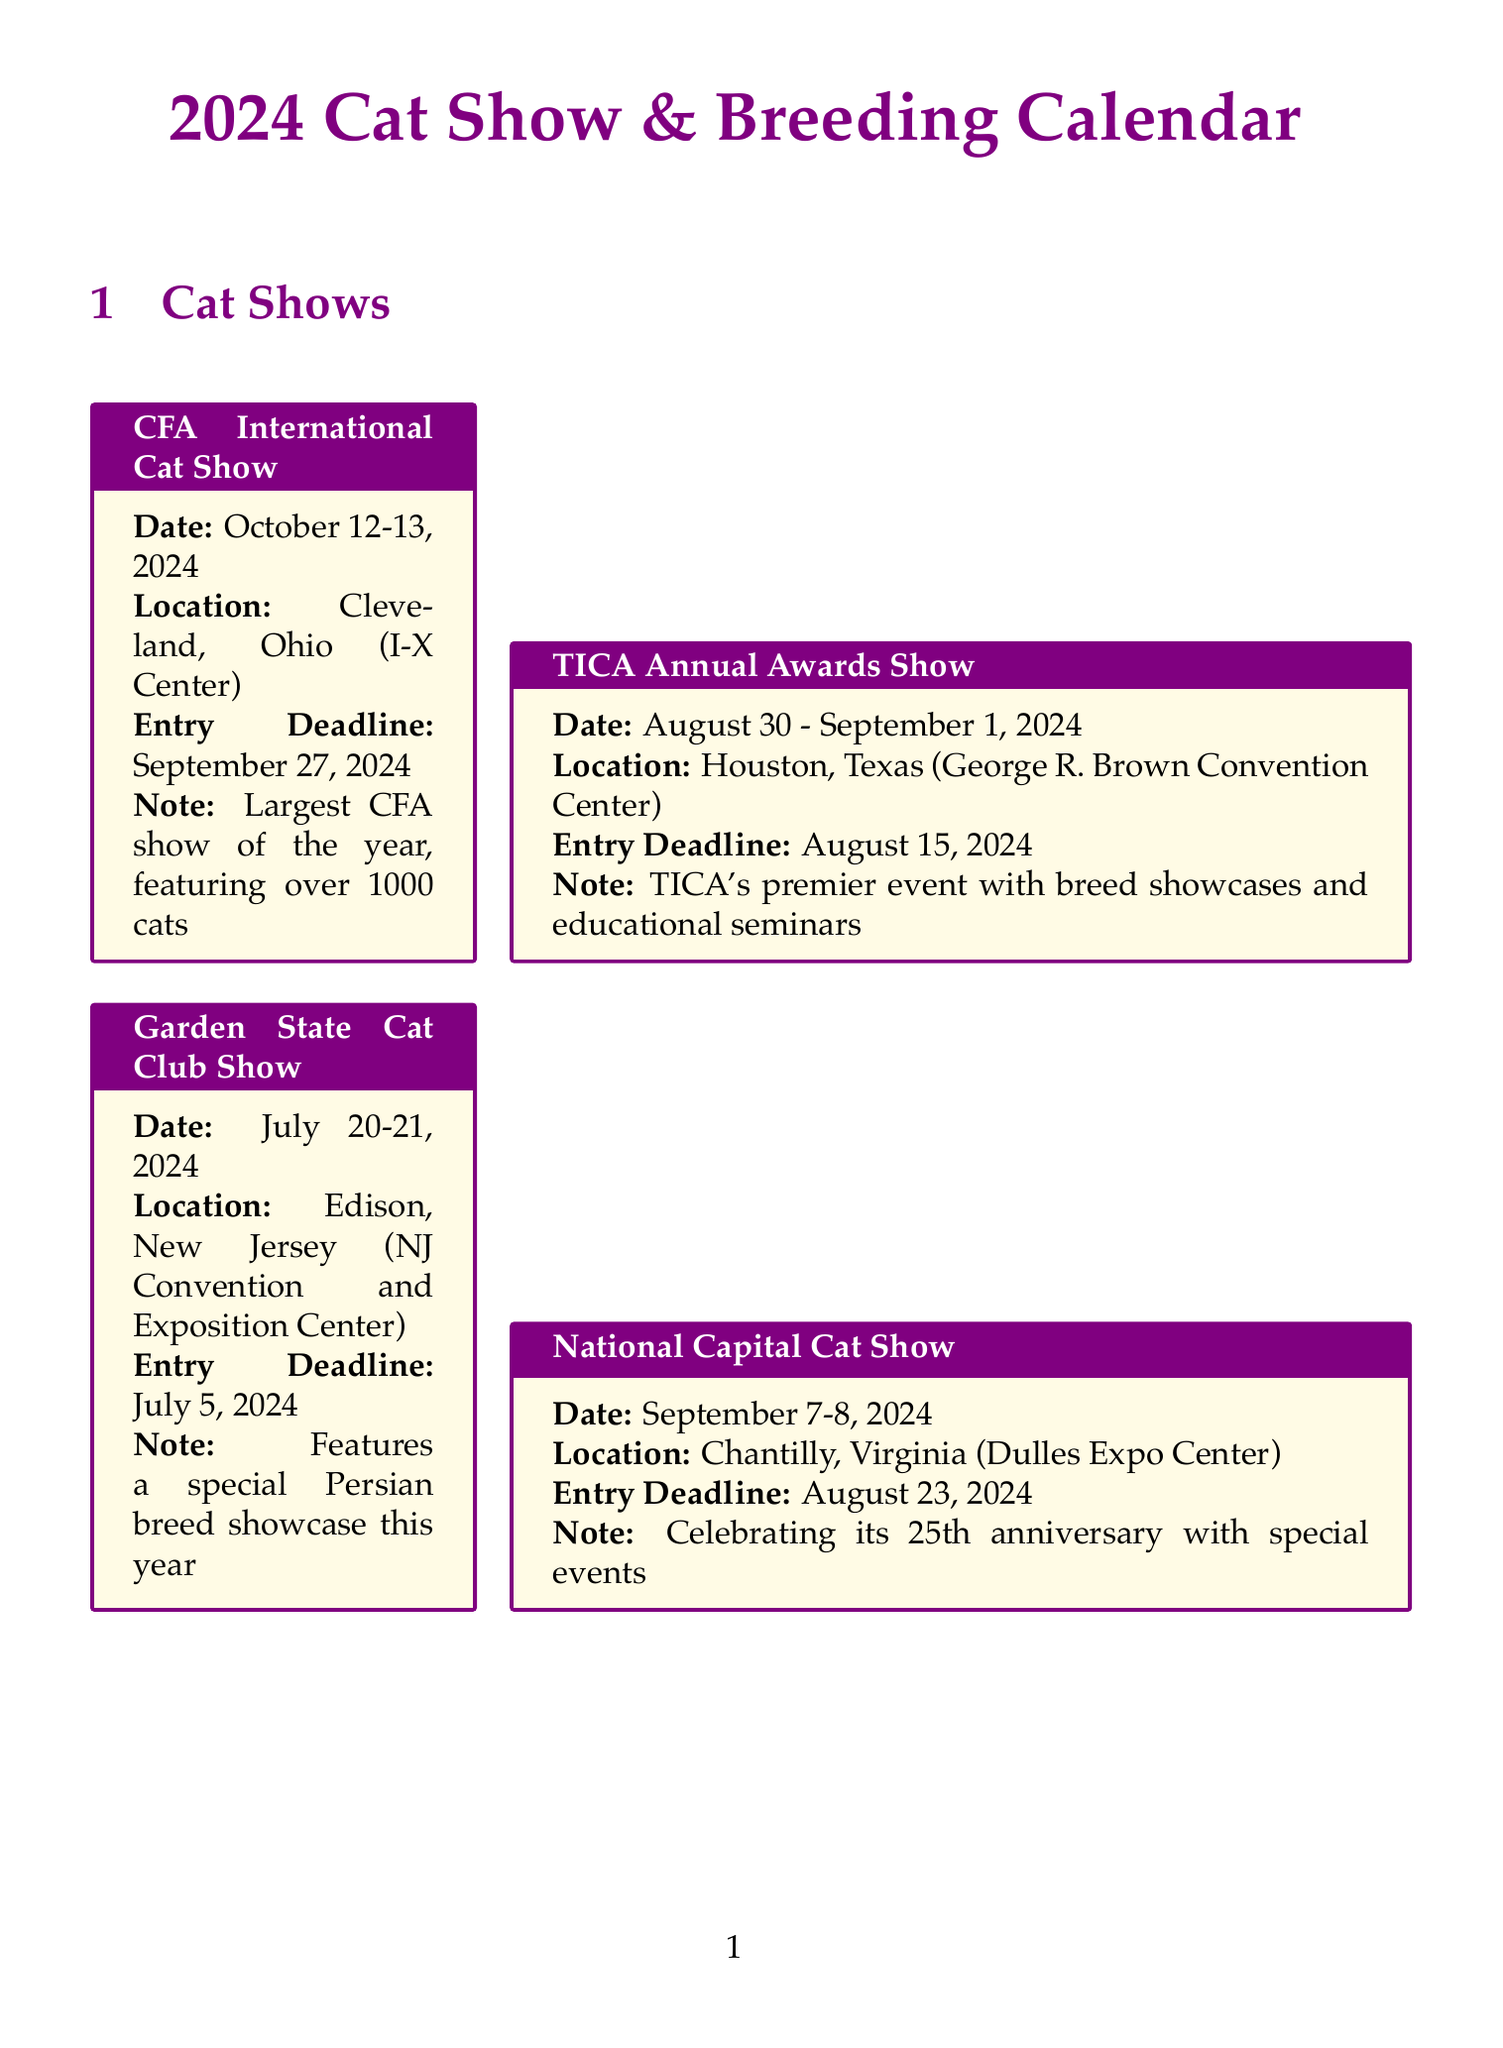What is the date of the CFA International Cat Show? The date of the CFA International Cat Show is explicitly mentioned in the document as October 12-13, 2024.
Answer: October 12-13, 2024 Where is the Garden State Cat Club Show held? The location of the Garden State Cat Club Show is specified as Edison, New Jersey.
Answer: Edison, New Jersey What is the entry deadline for the TICA Annual Awards Show? The entry deadline for the TICA Annual Awards Show is stated as August 15, 2024.
Answer: August 15, 2024 How many days is the Florida Feline Fanciers' Extravaganza? The number of days for the Florida Feline Fanciers' Extravaganza can be calculated from the given date range of February 9-10, 2024, which shows it's two days long.
Answer: 2 days Which seminar focuses on Feline Genetics? The document specifies that the Feline Genetics Workshop focuses on genetic topics related to felines.
Answer: Feline Genetics Workshop What special feature is included in the Great Lakes Region Cat Show? The special feature introduced in the Great Lakes Region Cat Show is a new kitten socialization area for spectators.
Answer: Kitten socialization area What is the registration deadline for the Advanced Cat Breeding Techniques Symposium? The registration deadline for the Advanced Cat Breeding Techniques Symposium is noted as October 18, 2024.
Answer: October 18, 2024 How many cat shows take place in May 2024? By referring to the list, it is clear that there is one cat show in May 2024, which is the Midwest Region Cat Fanciers' Show.
Answer: 1 What is the focus of the CFA Judging School? The focus of the CFA Judging School is described as hands-on training for aspiring cat show judges.
Answer: Hands-on training for aspiring cat show judges 